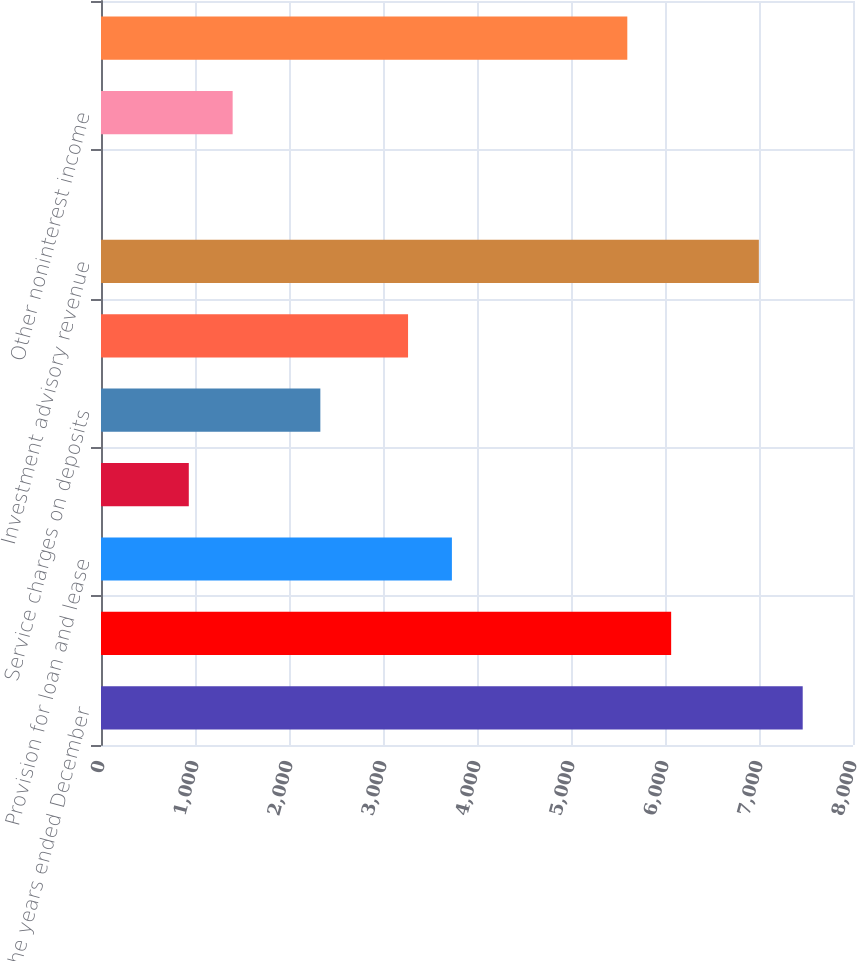<chart> <loc_0><loc_0><loc_500><loc_500><bar_chart><fcel>For the years ended December<fcel>Net interest income<fcel>Provision for loan and lease<fcel>Electronic payment processing<fcel>Service charges on deposits<fcel>Corporate banking revenue<fcel>Investment advisory revenue<fcel>Mortgage banking net revenue<fcel>Other noninterest income<fcel>Salaries incentives and<nl><fcel>7465<fcel>6065.5<fcel>3733<fcel>934<fcel>2333.5<fcel>3266.5<fcel>6998.5<fcel>1<fcel>1400.5<fcel>5599<nl></chart> 